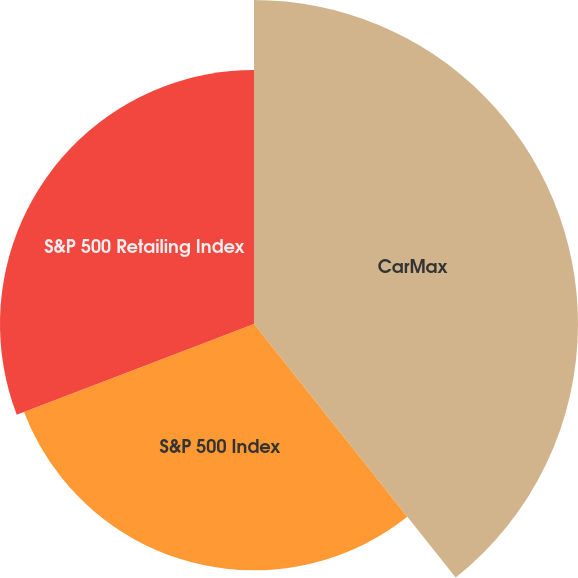Convert chart. <chart><loc_0><loc_0><loc_500><loc_500><pie_chart><fcel>CarMax<fcel>S&P 500 Index<fcel>S&P 500 Retailing Index<nl><fcel>39.31%<fcel>29.88%<fcel>30.82%<nl></chart> 